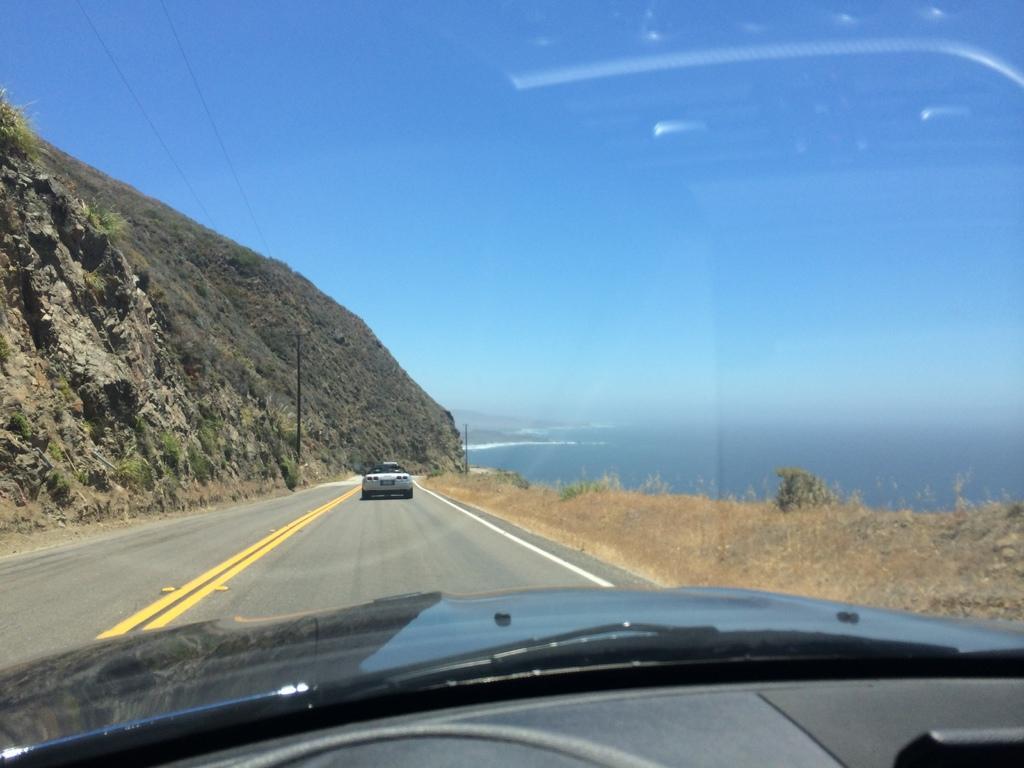In one or two sentences, can you explain what this image depicts? In this image I can see few vehicles, mountains, water and the dry grass. The sky is in blue and white color. 